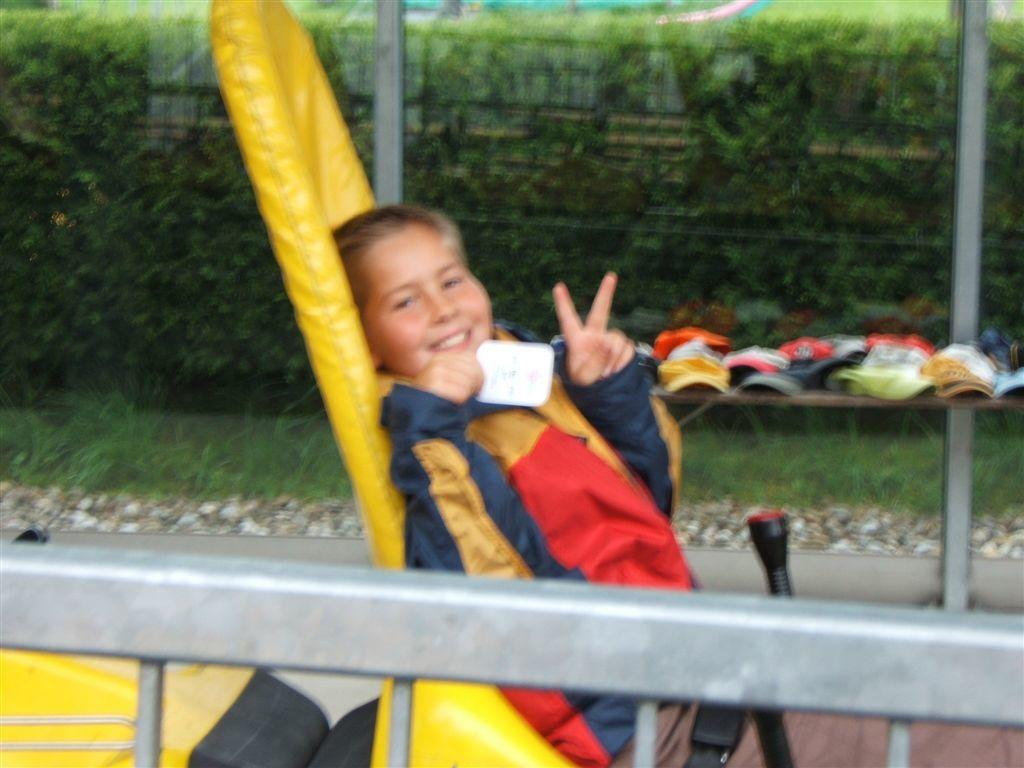What is the boy in the image doing? The boy is sitting in the image. What expression does the boy have? The boy is smiling. What can be seen on the table in the image? There are different caps on a table in the image. What type of vegetation is present in the image? There are plants in the image. What is in the foreground of the image? There is a railing in the foreground of the image. How many keys are hanging on the railing in the image? There are no keys visible in the image; only caps are present on the table. 